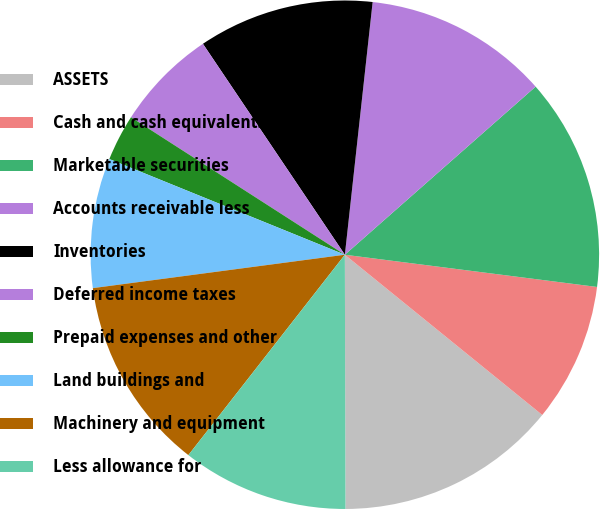<chart> <loc_0><loc_0><loc_500><loc_500><pie_chart><fcel>ASSETS<fcel>Cash and cash equivalents<fcel>Marketable securities<fcel>Accounts receivable less<fcel>Inventories<fcel>Deferred income taxes<fcel>Prepaid expenses and other<fcel>Land buildings and<fcel>Machinery and equipment<fcel>Less allowance for<nl><fcel>14.11%<fcel>8.83%<fcel>13.52%<fcel>11.76%<fcel>11.17%<fcel>6.48%<fcel>2.95%<fcel>8.24%<fcel>12.35%<fcel>10.59%<nl></chart> 